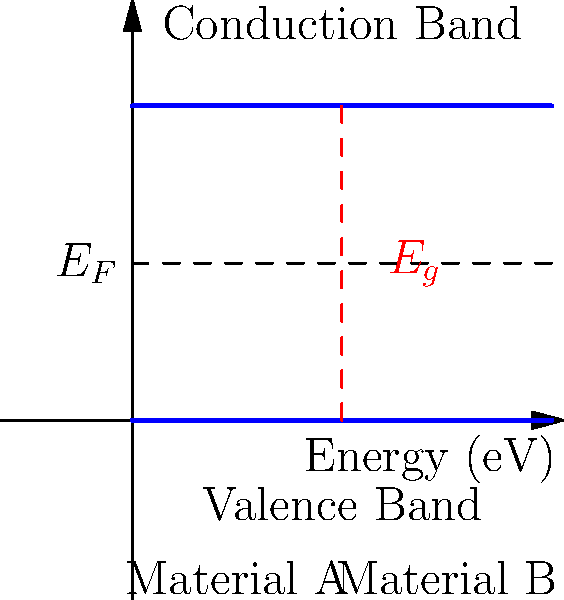In the semiconductor band gap diagram shown above, two different materials (A and B) are represented. Based on the diagram, which material would be more suitable for use in a solar cell application, and why? To determine which material would be more suitable for a solar cell application, we need to consider the band gap energy ($E_g$) of each material:

1. Analyze the diagram:
   - The diagram shows the conduction band, valence band, and Fermi level ($E_F$) for two materials, A and B.
   - The band gap ($E_g$) is the energy difference between the conduction band and valence band.

2. Compare band gaps:
   - Material A (left side) has a larger band gap than Material B (right side).
   - A larger band gap requires more energy for electrons to transition from the valence band to the conduction band.

3. Consider solar cell requirements:
   - Solar cells need to efficiently absorb photons from sunlight to generate electron-hole pairs.
   - The optimal band gap for solar cells is typically between 1.1 and 1.7 eV, close to the energy of visible light photons.

4. Evaluate suitability:
   - Material B has a smaller band gap, which is likely closer to the optimal range for solar cells.
   - A smaller band gap allows for the absorption of a wider range of photon energies from the solar spectrum.
   - Material A's larger band gap may result in lower efficiency, as it would only absorb higher-energy photons.

5. Consider other factors:
   - While not shown in the diagram, other properties such as carrier mobility, recombination rates, and material cost would also influence the final choice.

Based on the band gap information provided in the diagram, Material B would be more suitable for use in a solar cell application due to its smaller band gap, which is likely closer to the optimal range for efficient photon absorption from the solar spectrum.
Answer: Material B, due to its smaller band gap. 